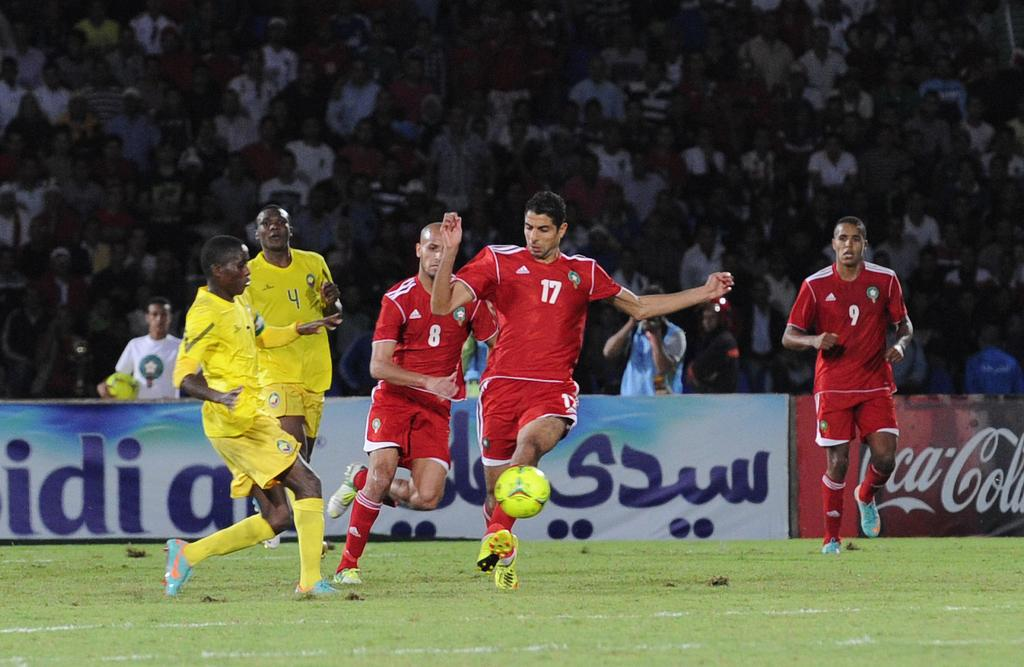<image>
Offer a succinct explanation of the picture presented. Red #17 kicks the ball away from the yellow team in front of a sign for Coca Cola. 